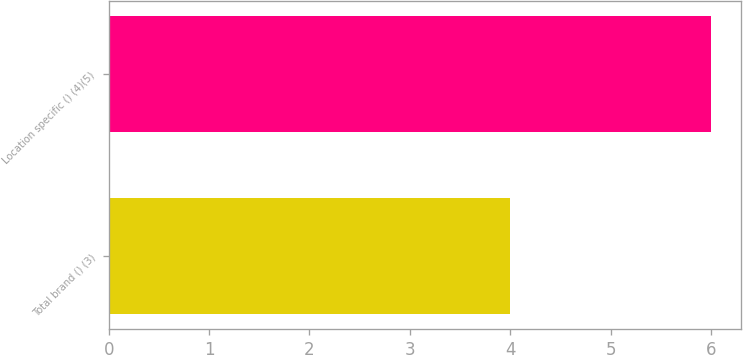Convert chart. <chart><loc_0><loc_0><loc_500><loc_500><bar_chart><fcel>Total brand () (3)<fcel>Location specific () (4)(5)<nl><fcel>4<fcel>6<nl></chart> 